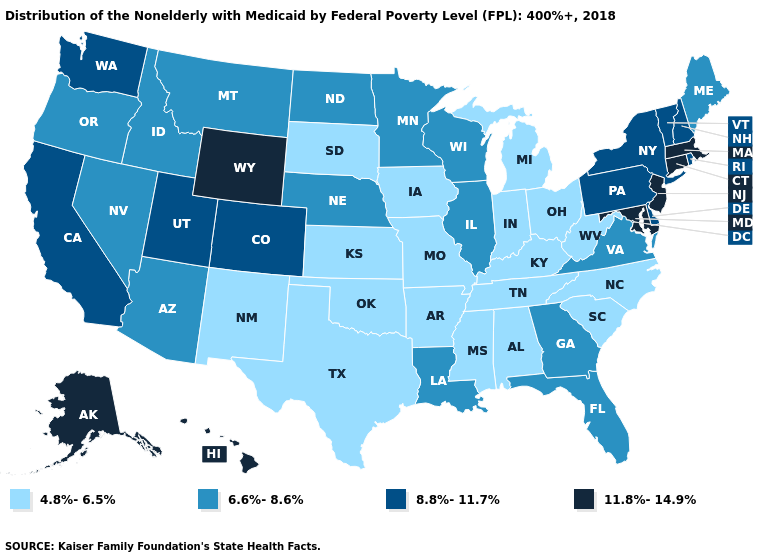How many symbols are there in the legend?
Keep it brief. 4. Name the states that have a value in the range 6.6%-8.6%?
Write a very short answer. Arizona, Florida, Georgia, Idaho, Illinois, Louisiana, Maine, Minnesota, Montana, Nebraska, Nevada, North Dakota, Oregon, Virginia, Wisconsin. Does Nebraska have a higher value than Kentucky?
Be succinct. Yes. Which states have the lowest value in the West?
Write a very short answer. New Mexico. Which states have the highest value in the USA?
Give a very brief answer. Alaska, Connecticut, Hawaii, Maryland, Massachusetts, New Jersey, Wyoming. What is the value of Kentucky?
Answer briefly. 4.8%-6.5%. Which states hav the highest value in the West?
Be succinct. Alaska, Hawaii, Wyoming. How many symbols are there in the legend?
Be succinct. 4. Does Idaho have a lower value than North Dakota?
Short answer required. No. Name the states that have a value in the range 6.6%-8.6%?
Keep it brief. Arizona, Florida, Georgia, Idaho, Illinois, Louisiana, Maine, Minnesota, Montana, Nebraska, Nevada, North Dakota, Oregon, Virginia, Wisconsin. What is the lowest value in states that border Indiana?
Quick response, please. 4.8%-6.5%. What is the value of Florida?
Be succinct. 6.6%-8.6%. Does New Jersey have the highest value in the Northeast?
Answer briefly. Yes. How many symbols are there in the legend?
Answer briefly. 4. Does the first symbol in the legend represent the smallest category?
Write a very short answer. Yes. 